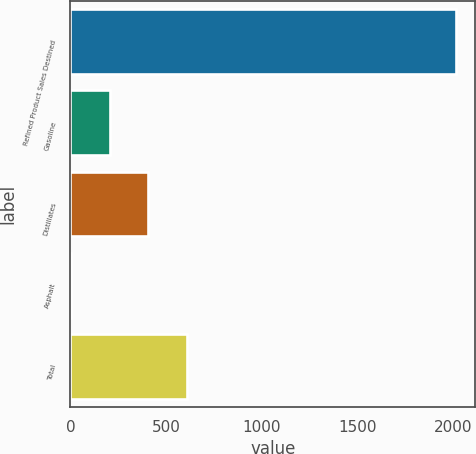<chart> <loc_0><loc_0><loc_500><loc_500><bar_chart><fcel>Refined Product Sales Destined<fcel>Gasoline<fcel>Distillates<fcel>Asphalt<fcel>Total<nl><fcel>2015<fcel>205.1<fcel>406.2<fcel>4<fcel>607.3<nl></chart> 